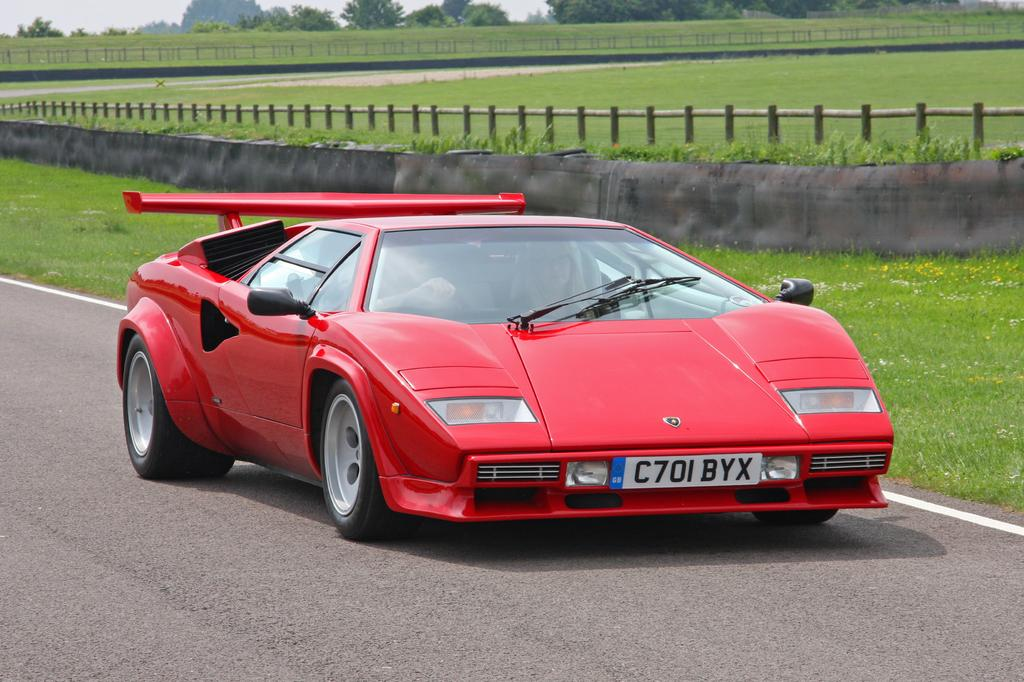What is the main subject of the image? The main subject of the image is a car on the road. How many people are in the car? There are two persons in the car. What can be seen in the background of the image? In the background of the image, there is grass, a wooden fence, and trees. What type of toy is the father playing with in the image? There is no father or toy present in the image; it features a car on the road with two people inside. 